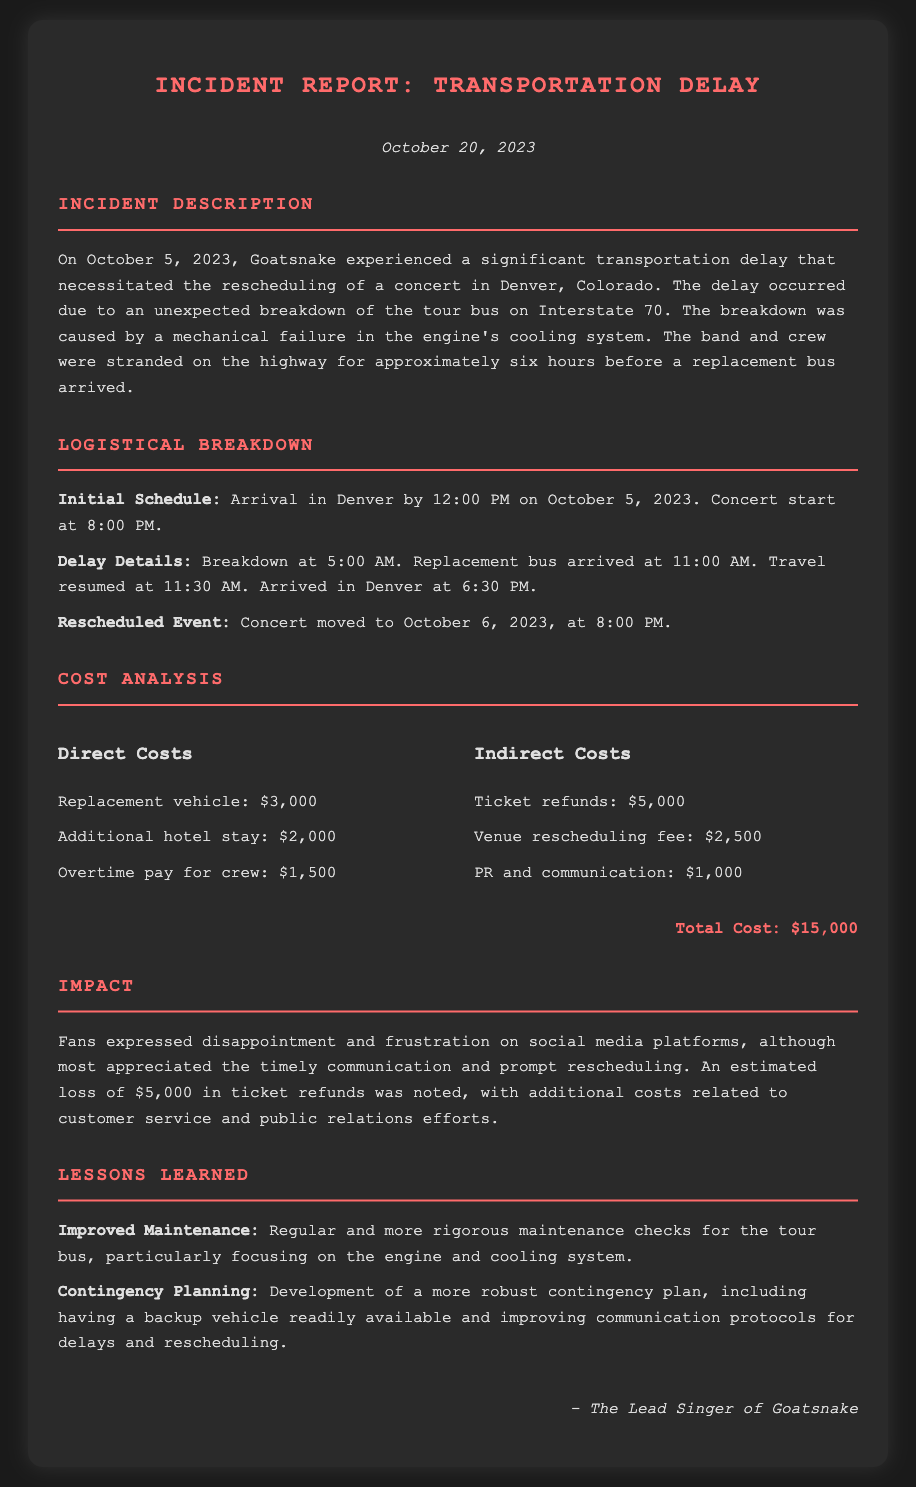What caused the transportation delay? The transportation delay was caused by a mechanical failure in the engine's cooling system of the tour bus.
Answer: mechanical failure in the engine's cooling system When did the breakdown occur? The breakdown occurred at 5:00 AM on October 5, 2023.
Answer: 5:00 AM on October 5, 2023 What was the total cost incurred due to the incident? The total cost is listed as $15,000 in the document.
Answer: $15,000 How long were the band and crew stranded before help arrived? The band and crew were stranded on the highway for approximately six hours.
Answer: six hours On what date was the concert rescheduled? The concert was rescheduled to October 6, 2023, at 8:00 PM.
Answer: October 6, 2023 What were the ticket refunds recorded? The ticket refunds were noted as $5,000.
Answer: $5,000 What improvements are suggested for future maintenance? The document suggests improved maintenance checks for the tour bus, especially for the engine and cooling system.
Answer: improved maintenance checks What should the contingency plan include? The contingency plan should include having a backup vehicle readily available and improving communication protocols.
Answer: backup vehicle and improving communication protocols 